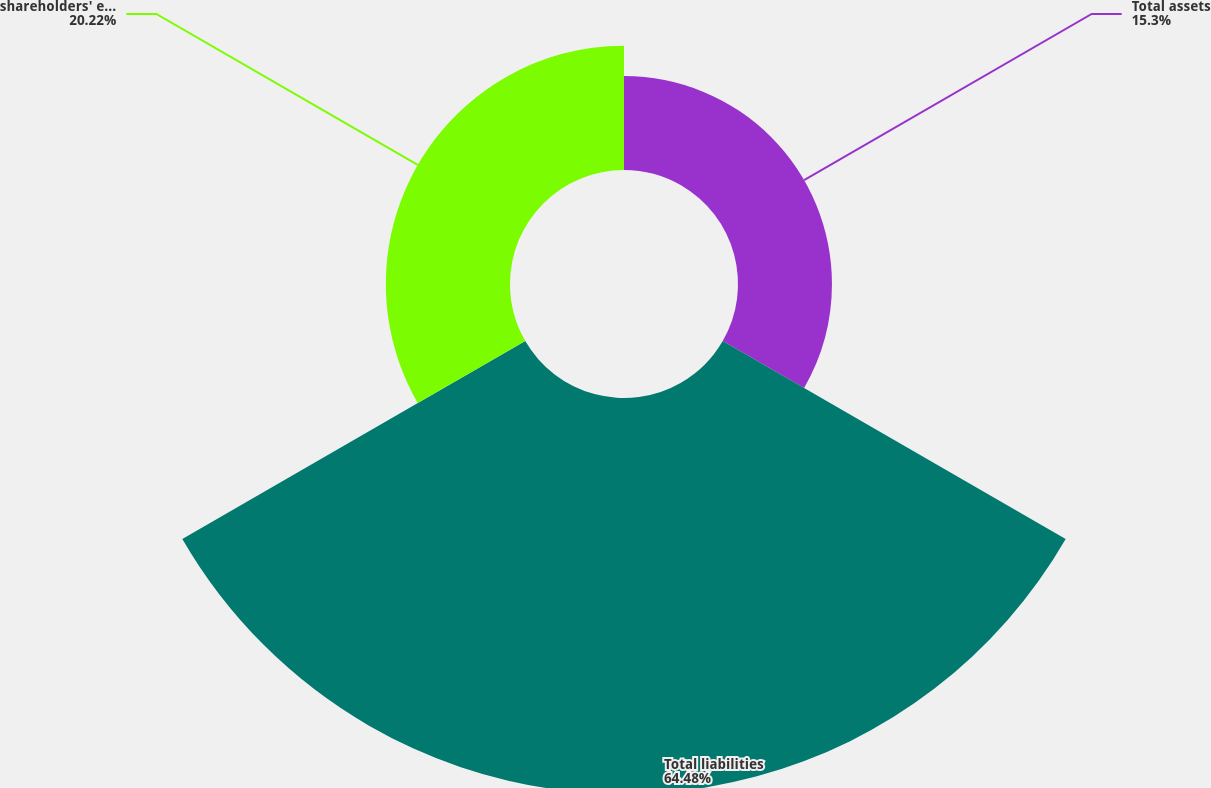Convert chart. <chart><loc_0><loc_0><loc_500><loc_500><pie_chart><fcel>Total assets<fcel>Total liabilities<fcel>shareholders' equity<nl><fcel>15.3%<fcel>64.49%<fcel>20.22%<nl></chart> 